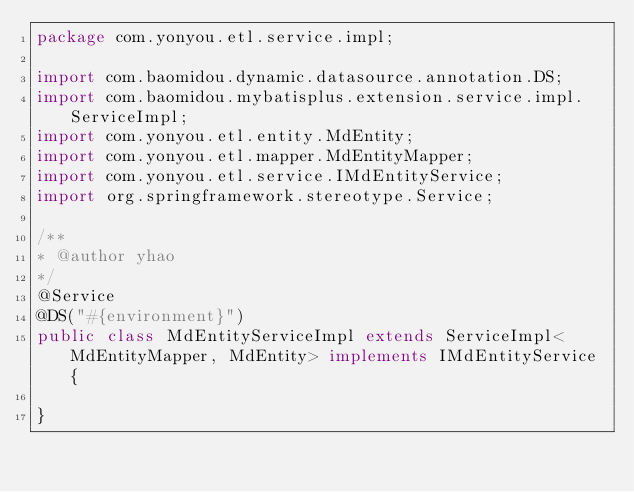Convert code to text. <code><loc_0><loc_0><loc_500><loc_500><_Java_>package com.yonyou.etl.service.impl;

import com.baomidou.dynamic.datasource.annotation.DS;
import com.baomidou.mybatisplus.extension.service.impl.ServiceImpl;
import com.yonyou.etl.entity.MdEntity;
import com.yonyou.etl.mapper.MdEntityMapper;
import com.yonyou.etl.service.IMdEntityService;
import org.springframework.stereotype.Service;

/**
* @author yhao
*/
@Service
@DS("#{environment}")
public class MdEntityServiceImpl extends ServiceImpl<MdEntityMapper, MdEntity> implements IMdEntityService {

}
</code> 